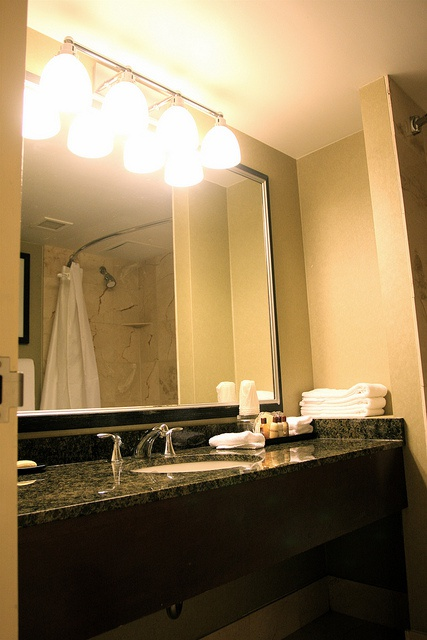Describe the objects in this image and their specific colors. I can see sink in olive and tan tones, bottle in olive, tan, and lightyellow tones, bottle in olive, orange, brown, and maroon tones, bottle in olive, orange, khaki, and maroon tones, and bottle in olive, brown, maroon, and tan tones in this image. 